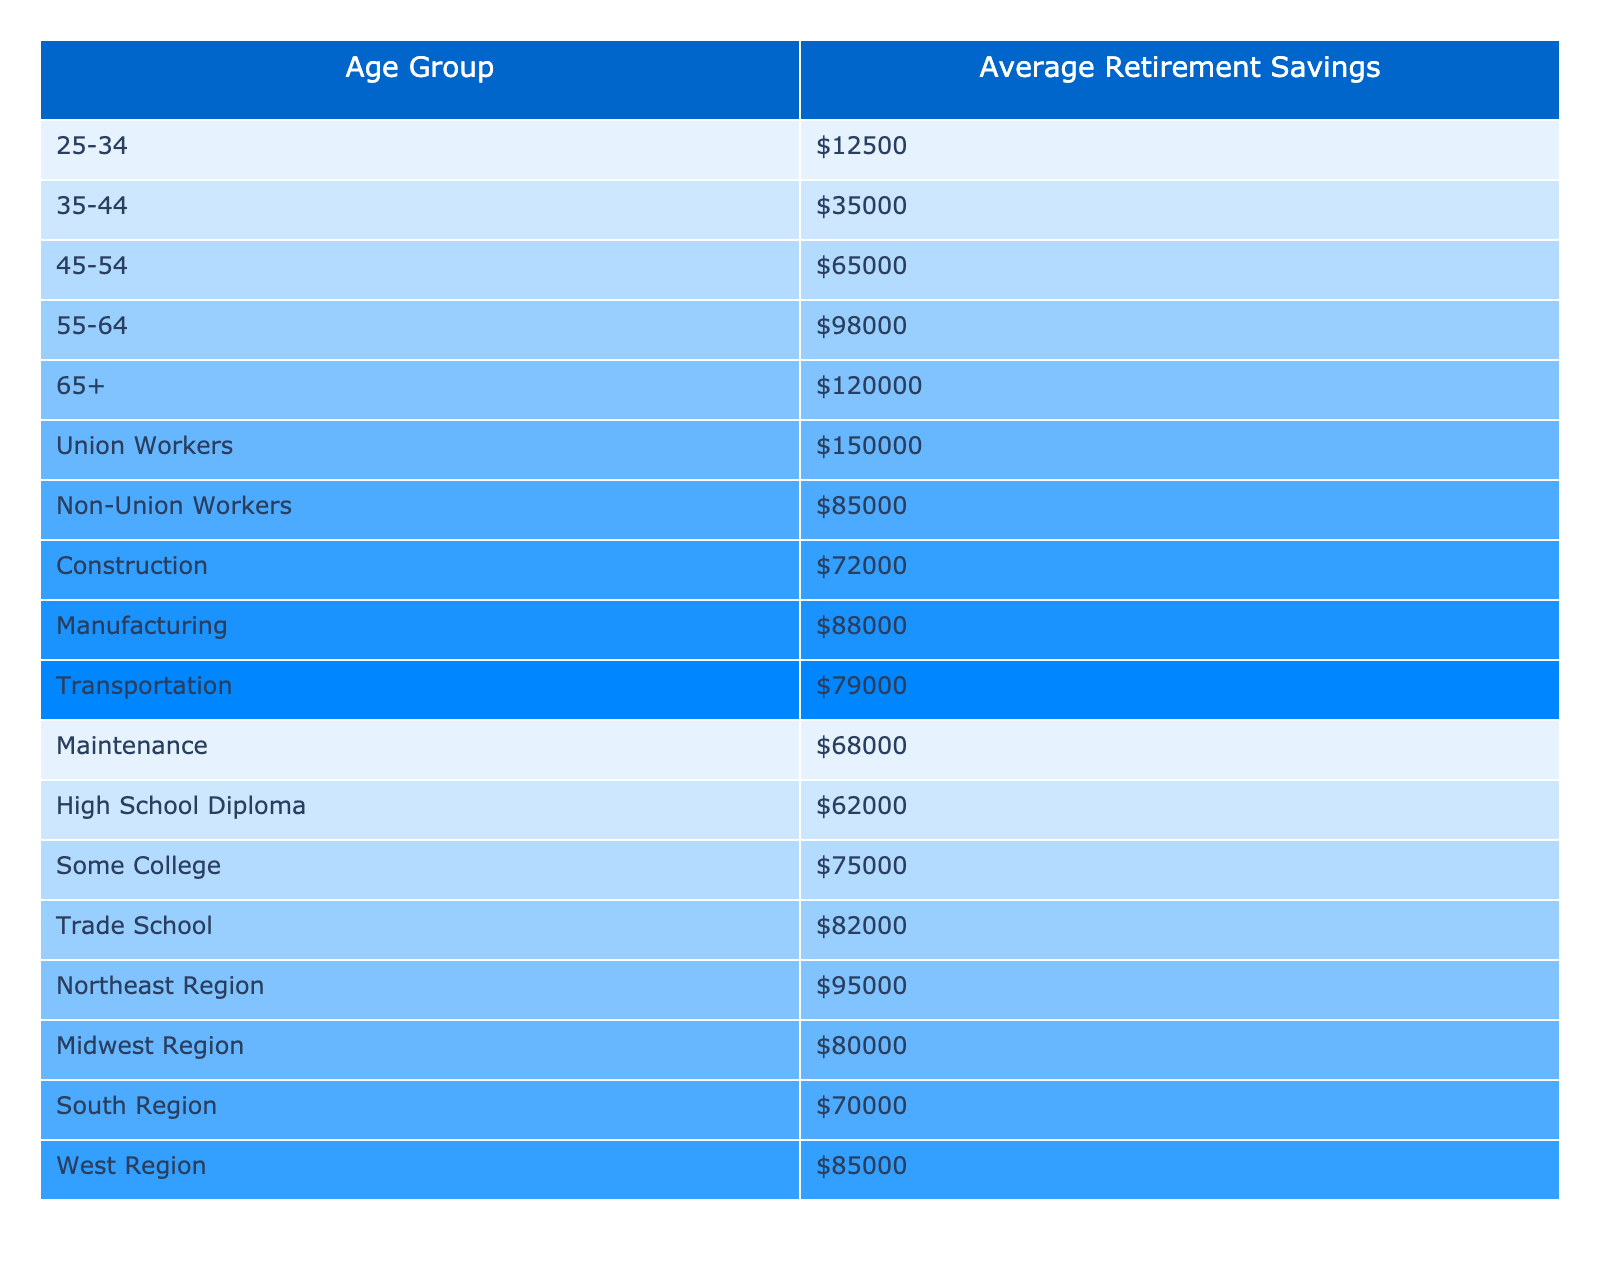What is the average retirement savings for workers aged 25-34? According to the table, the average retirement savings for the age group 25-34 is $12,500.
Answer: $12,500 What is the average retirement savings for non-union workers? The average retirement savings for non-union workers is given as $85,000 in the table.
Answer: $85,000 Which age group has the highest average retirement savings? The age group 65+ has the highest average retirement savings, which is $120,000.
Answer: $120,000 What is the average retirement savings for union workers compared to the average savings of workers aged 45-54? The average savings for union workers is $150,000 and for those aged 45-54, it's $65,000. The difference is $150,000 - $65,000 = $85,000, indicating that union workers save significantly more.
Answer: $85,000 more Is the average retirement savings higher for high school diploma holders than for trade school graduates? The average for high school diploma holders is $62,000, while trade school graduates have an average of $82,000. Since $62,000 is less than $82,000, the statement is false.
Answer: No What is the combined average retirement savings for all age groups from 25-64? The average savings for age groups from 25-64 are $12,500 (25-34) + $35,000 (35-44) + $65,000 (45-54) + $98,000 (55-64) = $210,500. The combined total for four groups divided by 4 equals an average of $52,625.
Answer: $52,625 Which region has the lowest average retirement savings? The South region has the lowest average retirement savings at $70,000 as identified in the table.
Answer: South Region Are construction workers saving more than those in transportation? Construction workers have an average savings of $72,000, while transportation workers average $79,000. Since $72,000 is less than $79,000, construction workers save less.
Answer: No If we only look at the average savings of people in the Midwest Region and non-union workers, what would that average be? The Midwest Region average is $80,000 and non-union workers average $85,000. To find the combined average, we calculate: ($80,000 + $85,000) / 2 = $82,500.
Answer: $82,500 What is the average retirement savings for blue-collar workers with some college education? The average retirement savings for workers with some college education is $75,000, according to the table.
Answer: $75,000 